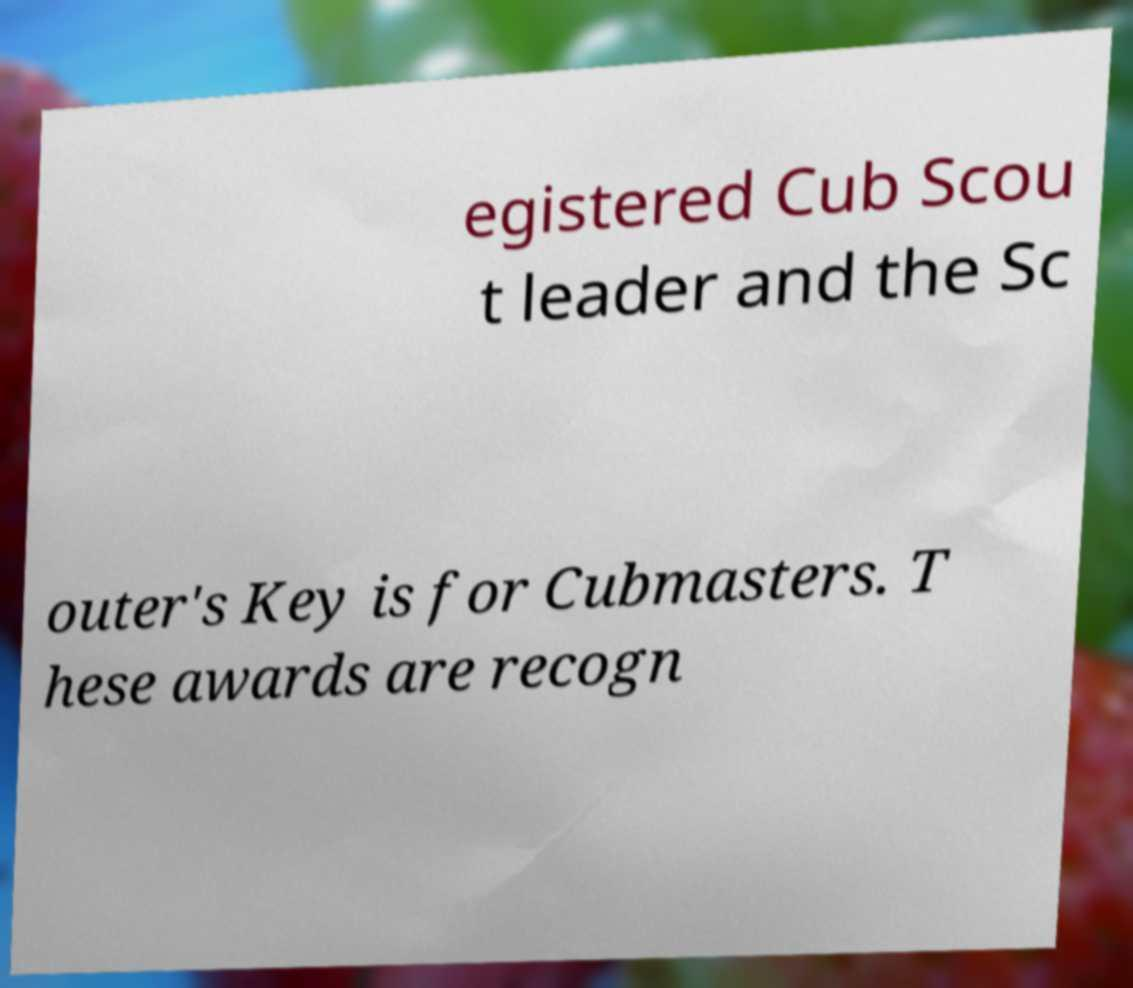Can you read and provide the text displayed in the image?This photo seems to have some interesting text. Can you extract and type it out for me? egistered Cub Scou t leader and the Sc outer's Key is for Cubmasters. T hese awards are recogn 